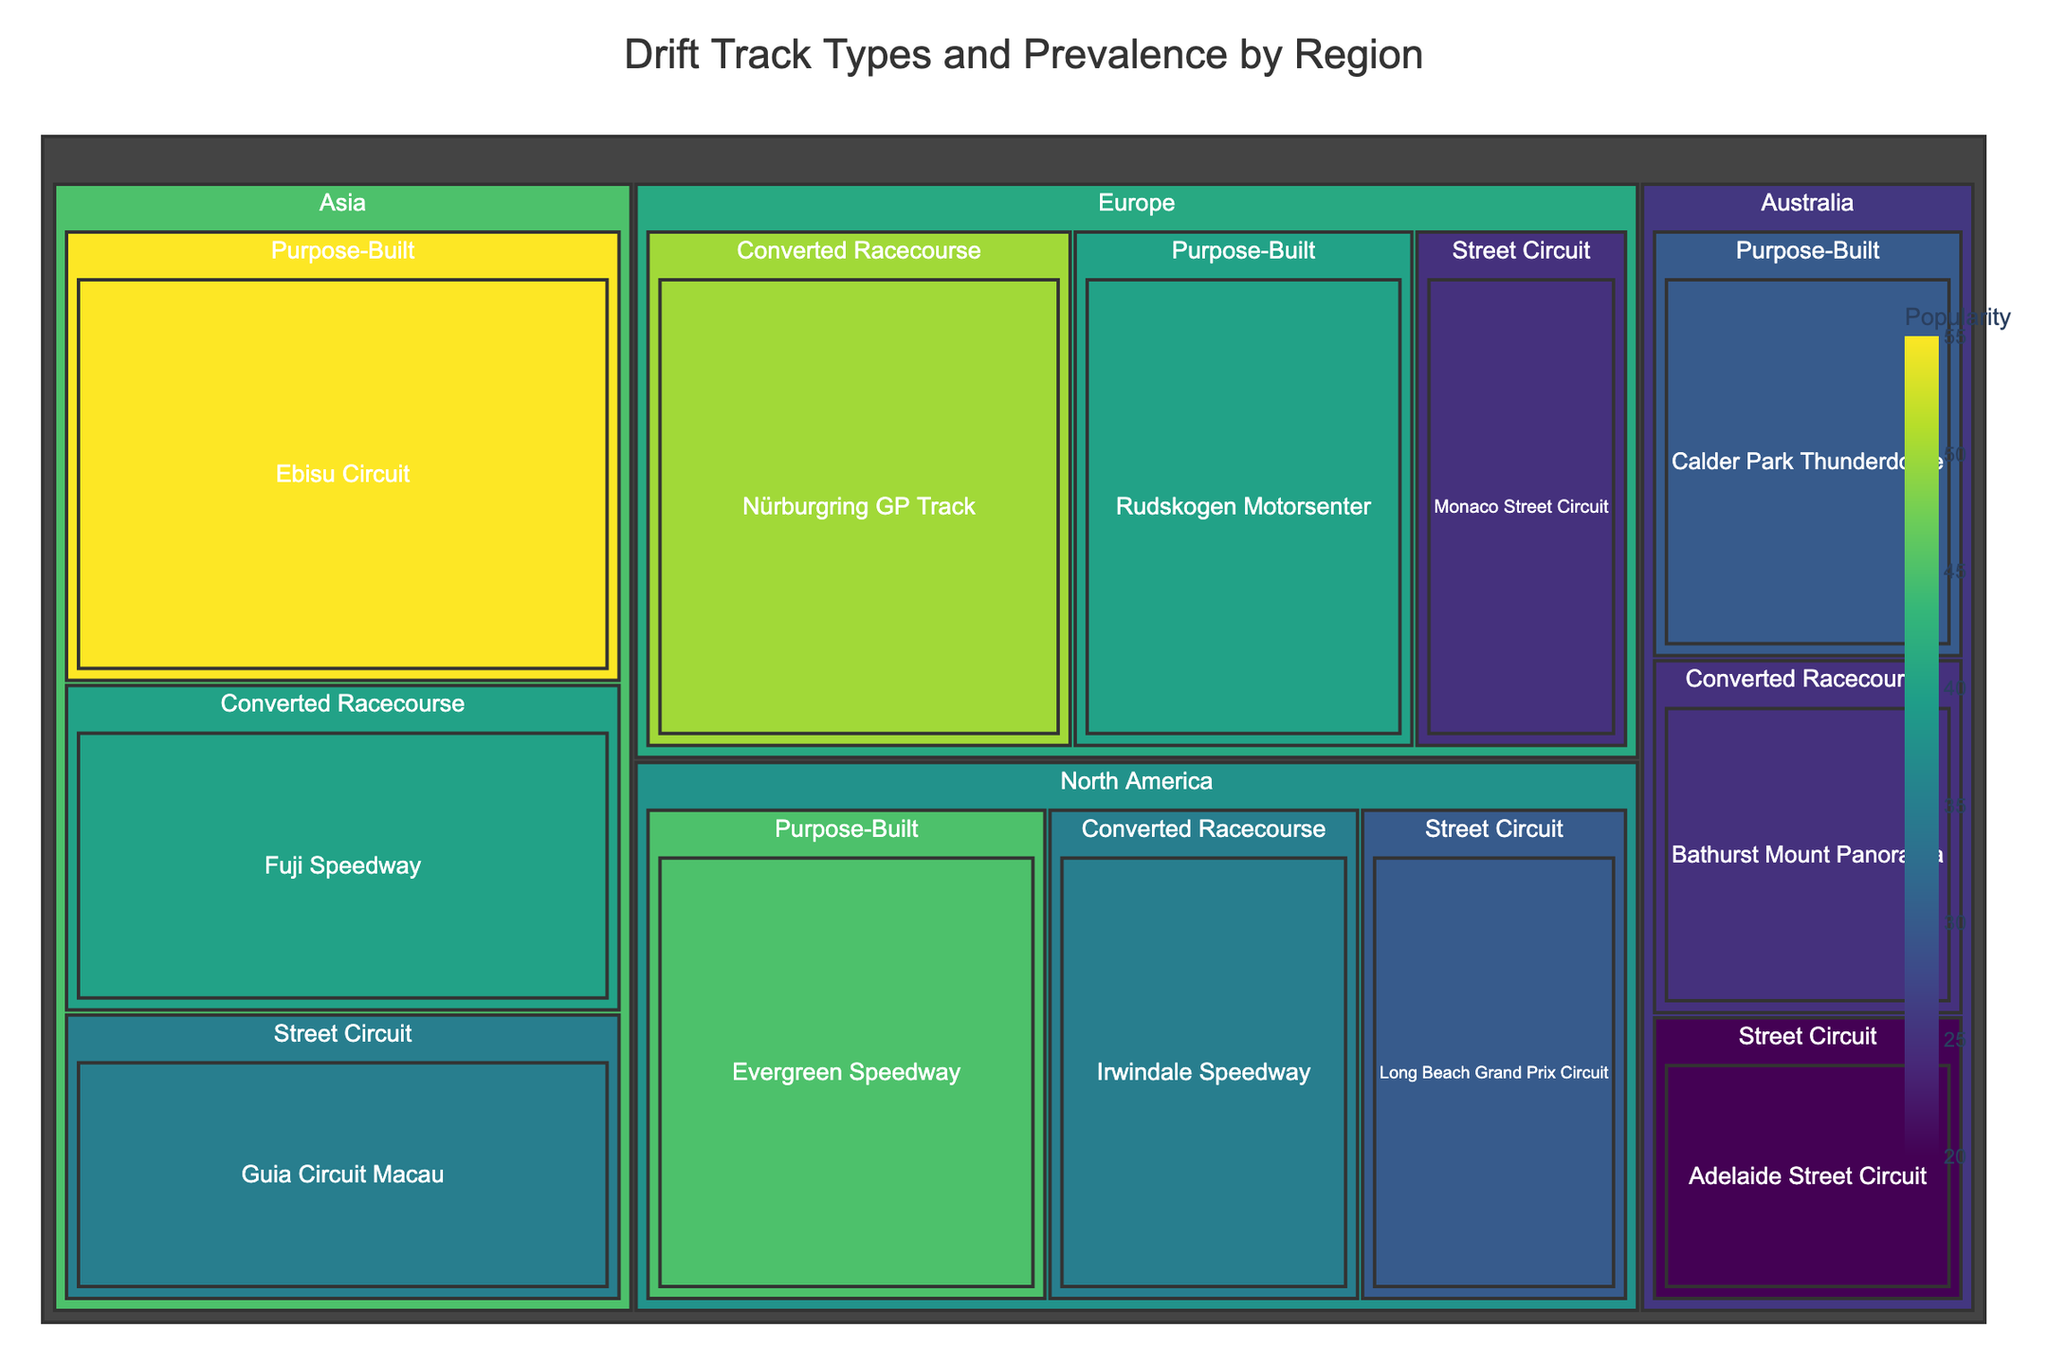What regions are represented in the treemap? The treemap is organized by regions as one of the main categories. By examining the outermost labels, we can identify the regions present in the treemap.
Answer: North America, Europe, Asia, Australia Which region has the most popular purpose-built track? To find this, we check the popularity values of purpose-built tracks under each region. The purpose-built track with the highest popularity is in the Asia region.
Answer: Asia What is the name of the most popular street circuit? The name of the most popular street circuit can be identified by checking the "Popularity" values under "Street Circuit" categories. The Guia Circuit Macau in Asia has the highest popularity.
Answer: Guia Circuit Macau How does the popularity of converted racecourses in Europe compare to those in other regions? By examining the "Converted Racecourse" subcategories under each region and noting their popularity values, we see that the Nürburgring GP Track in Europe has a popularity of 50, which is higher than those in North America, Asia, and Australia.
Answer: Europe has higher popularity What is the total popularity of all street circuits? To calculate the total popularity of all street circuits, we need to sum the popularity values of street circuits from all regions. The values are 30 (North America) + 25 (Europe) + 35 (Asia) + 20 (Australia) = 110.
Answer: 110 Which track type is most prevalent in North America in terms of popularity? We compare the popularity values of "Street Circuit," "Purpose-Built," and "Converted Racecourse" under the North America region. The "Purpose-Built" track type (Evergreen Speedway) has the highest popularity with 45.
Answer: Purpose-Built What is the average popularity of tracks in Europe? To find the average popularity, sum the popularity values of all tracks in Europe and divide by the number of tracks. The values are 25 (Street Circuit) + 40 (Purpose-Built) + 50 (Converted Racecourse) = 115. There are 3 tracks, so the average is 115 / 3 ≈ 38.33.
Answer: 38.33 Which region has the least popular converted racecourse? To determine this, we compare the popularity of converted racecourses in each region. Australia (Bathurst Mount Panorama) has the least popularity with 25.
Answer: Australia What is the difference in popularity between the most popular purpose-built track and the least popular street circuit? The most popular purpose-built track is Ebisu Circuit in Asia with 55 popularity, and the least popular street circuit is Adelaide Street Circuit in Australia with 20 popularity. The difference is 55 - 20 = 35.
Answer: 35 